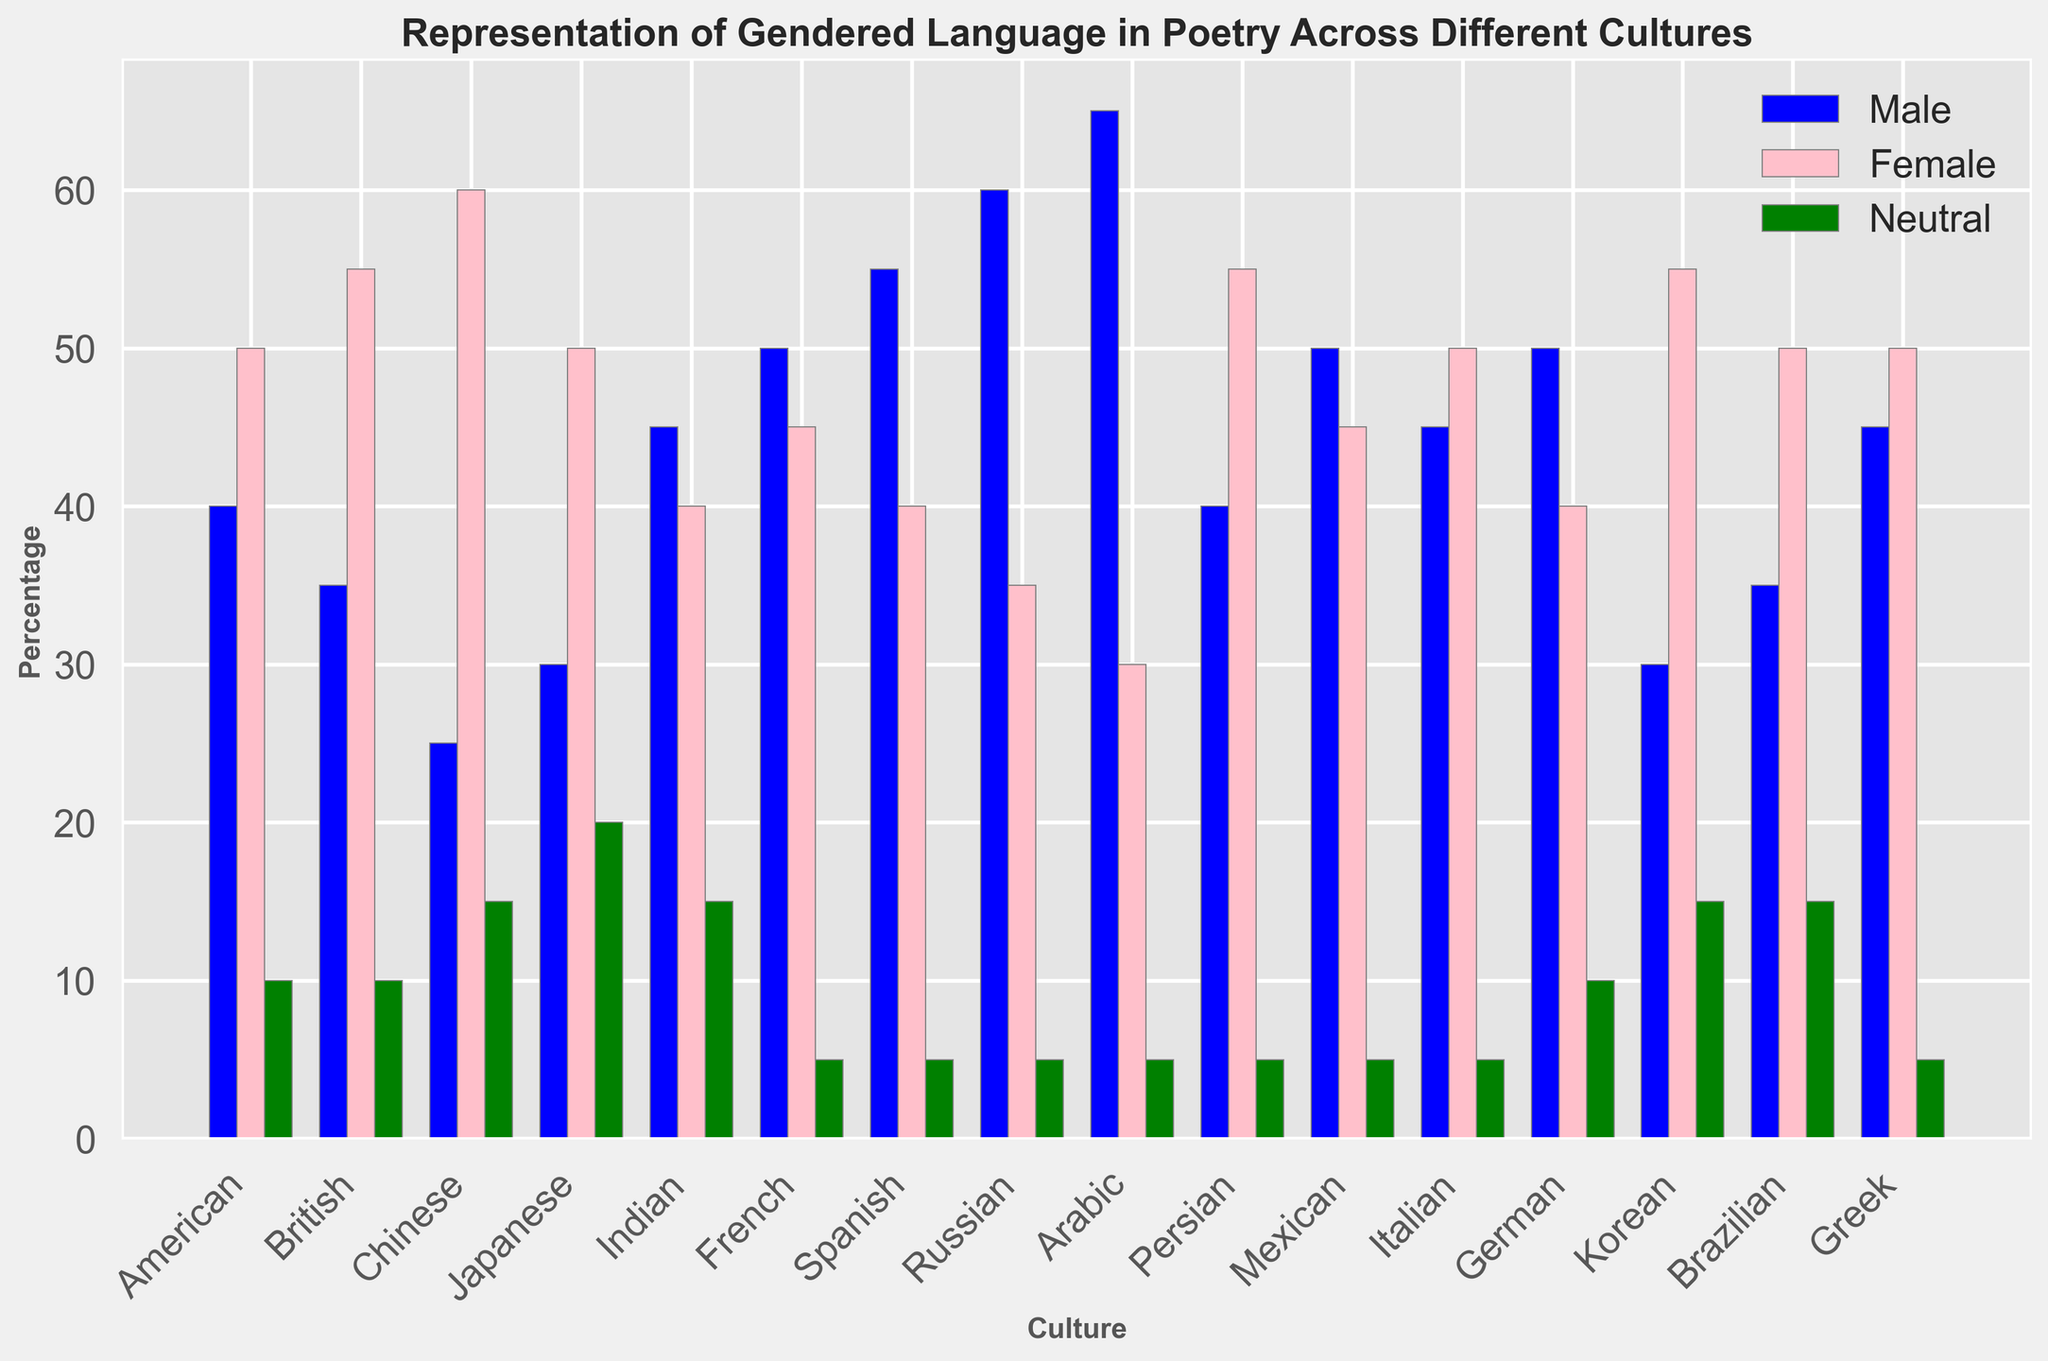Which culture has the highest percentage of male gendered language in poetry? To find the culture with the highest percentage of male gendered language, look at the blue bars representing male gendered language percentages and identify the tallest one. The tallest blue bar is for Arabic culture.
Answer: Arabic Between American and British cultures, which one uses more neutral gendered language in poetry? Compare the green bars that represent the percentage of neutral gendered language for both American and British cultures. Both have the same percentage for neutral language (10%).
Answer: Both are equal What is the difference in the percentage of female gendered language between Chinese and Persian cultures? Look at the pink bars for Chinese and Persian cultures. Chinese culture has a 60% usage, while Persian has 55%. The difference is 60% - 55% = 5%.
Answer: 5% Which two cultures have the same percentage of neutral gendered language in poetry? Look at the green bars to compare the percentage of neutral gendered language. American and British cultures both have 10% as seen by the green bars being equal in height.
Answer: American and British What is the average percentage of male gendered language across all cultures? Sum up the percentages of male gendered language for all cultures and then divide by the number of cultures (16). Calculation: (40 + 35 + 25 + 30 + 45 + 50 + 55 + 60 + 65 + 40 + 50 + 45 + 50 + 30 + 35 + 45) / 16 = 720 / 16 = 45.
Answer: 45 Which culture has the most balanced use of male and female gendered language? Check for the smallest difference in percentage between blue and pink bars for each culture. Japanese culture has both male and female percentages at 50%, making it the most balanced.
Answer: Japanese What is the total percentage of neutral gendered language used by Japanese and German cultures combined? Add the percentage of neutral gendered language for Japanese (20%) and German (10%). Calculation: 20% + 10% = 30%.
Answer: 30 How does the use of female gendered language in Greek poetry compare with that in Arabic poetry? Compare the pink bars for Greek and Arabic cultures. Greek has 50% and Arabic has 30%. Greek culture uses more female gendered language.
Answer: Greek uses more Which culture has the least percentage of neutral gendered language? Identify the shortest green bar, which represents the percentage of neutral gendered language. The shortest green bars, equal in the 5% category, include French, Spanish, Russian, Arabic, Persian, Mexican, Italian, and Greek.
Answer: Several cultures at 5% What is the median percentage of male gendered language in the dataset? Sort the percentages of male gendered language ((25, 30, 30, 35, 35, 40, 40, 45, 45, 45, 50, 50, 50, 55, 60, 65)) and find the middle value. Since there are an even number of values (16), calculate the average of the 8th and 9th values. (45 + 45) / 2 = 45.
Answer: 45 